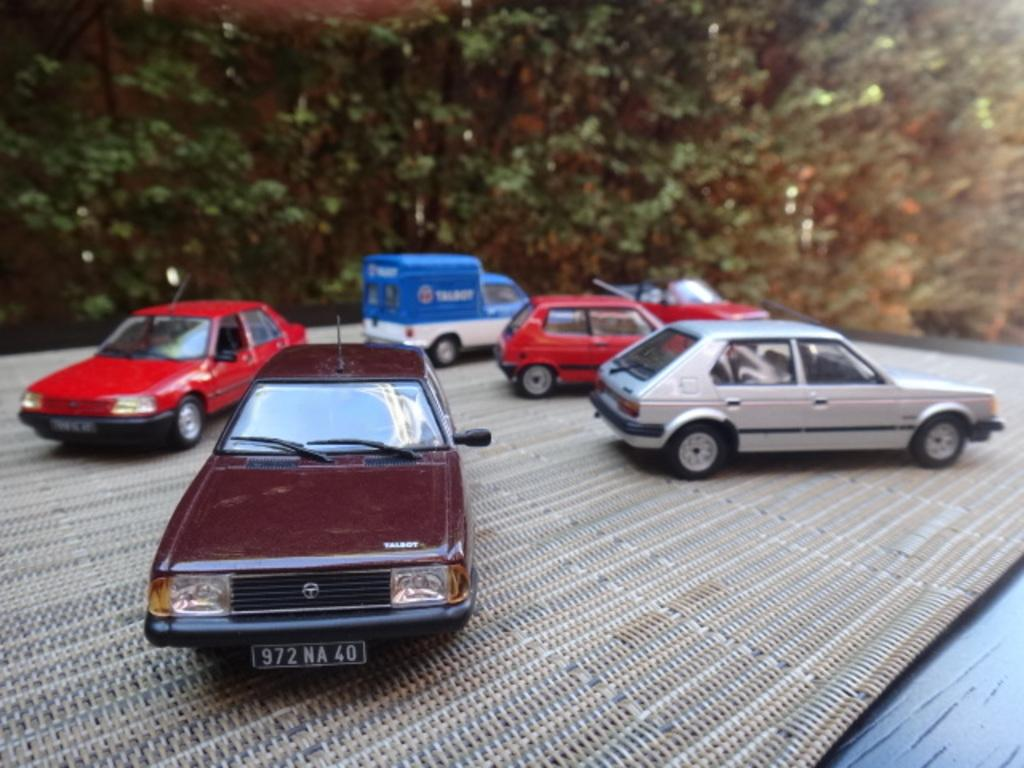What type of objects are present in the image? There are toy vehicles in the image. Can you describe the toy vehicles? The toy vehicles are in different colors. What is the surface on which the toy vehicles are placed? The vehicles are on a cream and grey color surface. What can be seen in the background of the image? There are many trees in the background of the image. What type of mist can be seen surrounding the toy vehicles in the image? There is no mist present in the image; it features toy vehicles on a surface with trees in the background. 